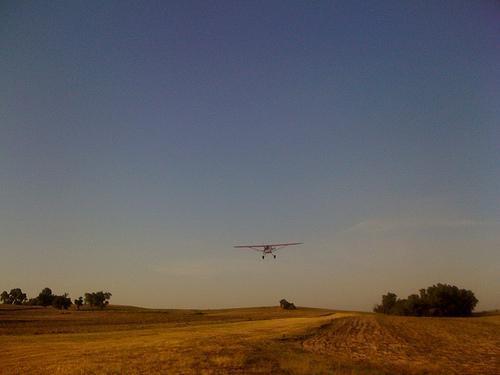How many planes are in the photo?
Give a very brief answer. 1. How many wheels does the plane have?
Give a very brief answer. 2. How many wings are on the plane?
Give a very brief answer. 2. 